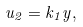<formula> <loc_0><loc_0><loc_500><loc_500>u _ { 2 } = k _ { 1 } y ,</formula> 